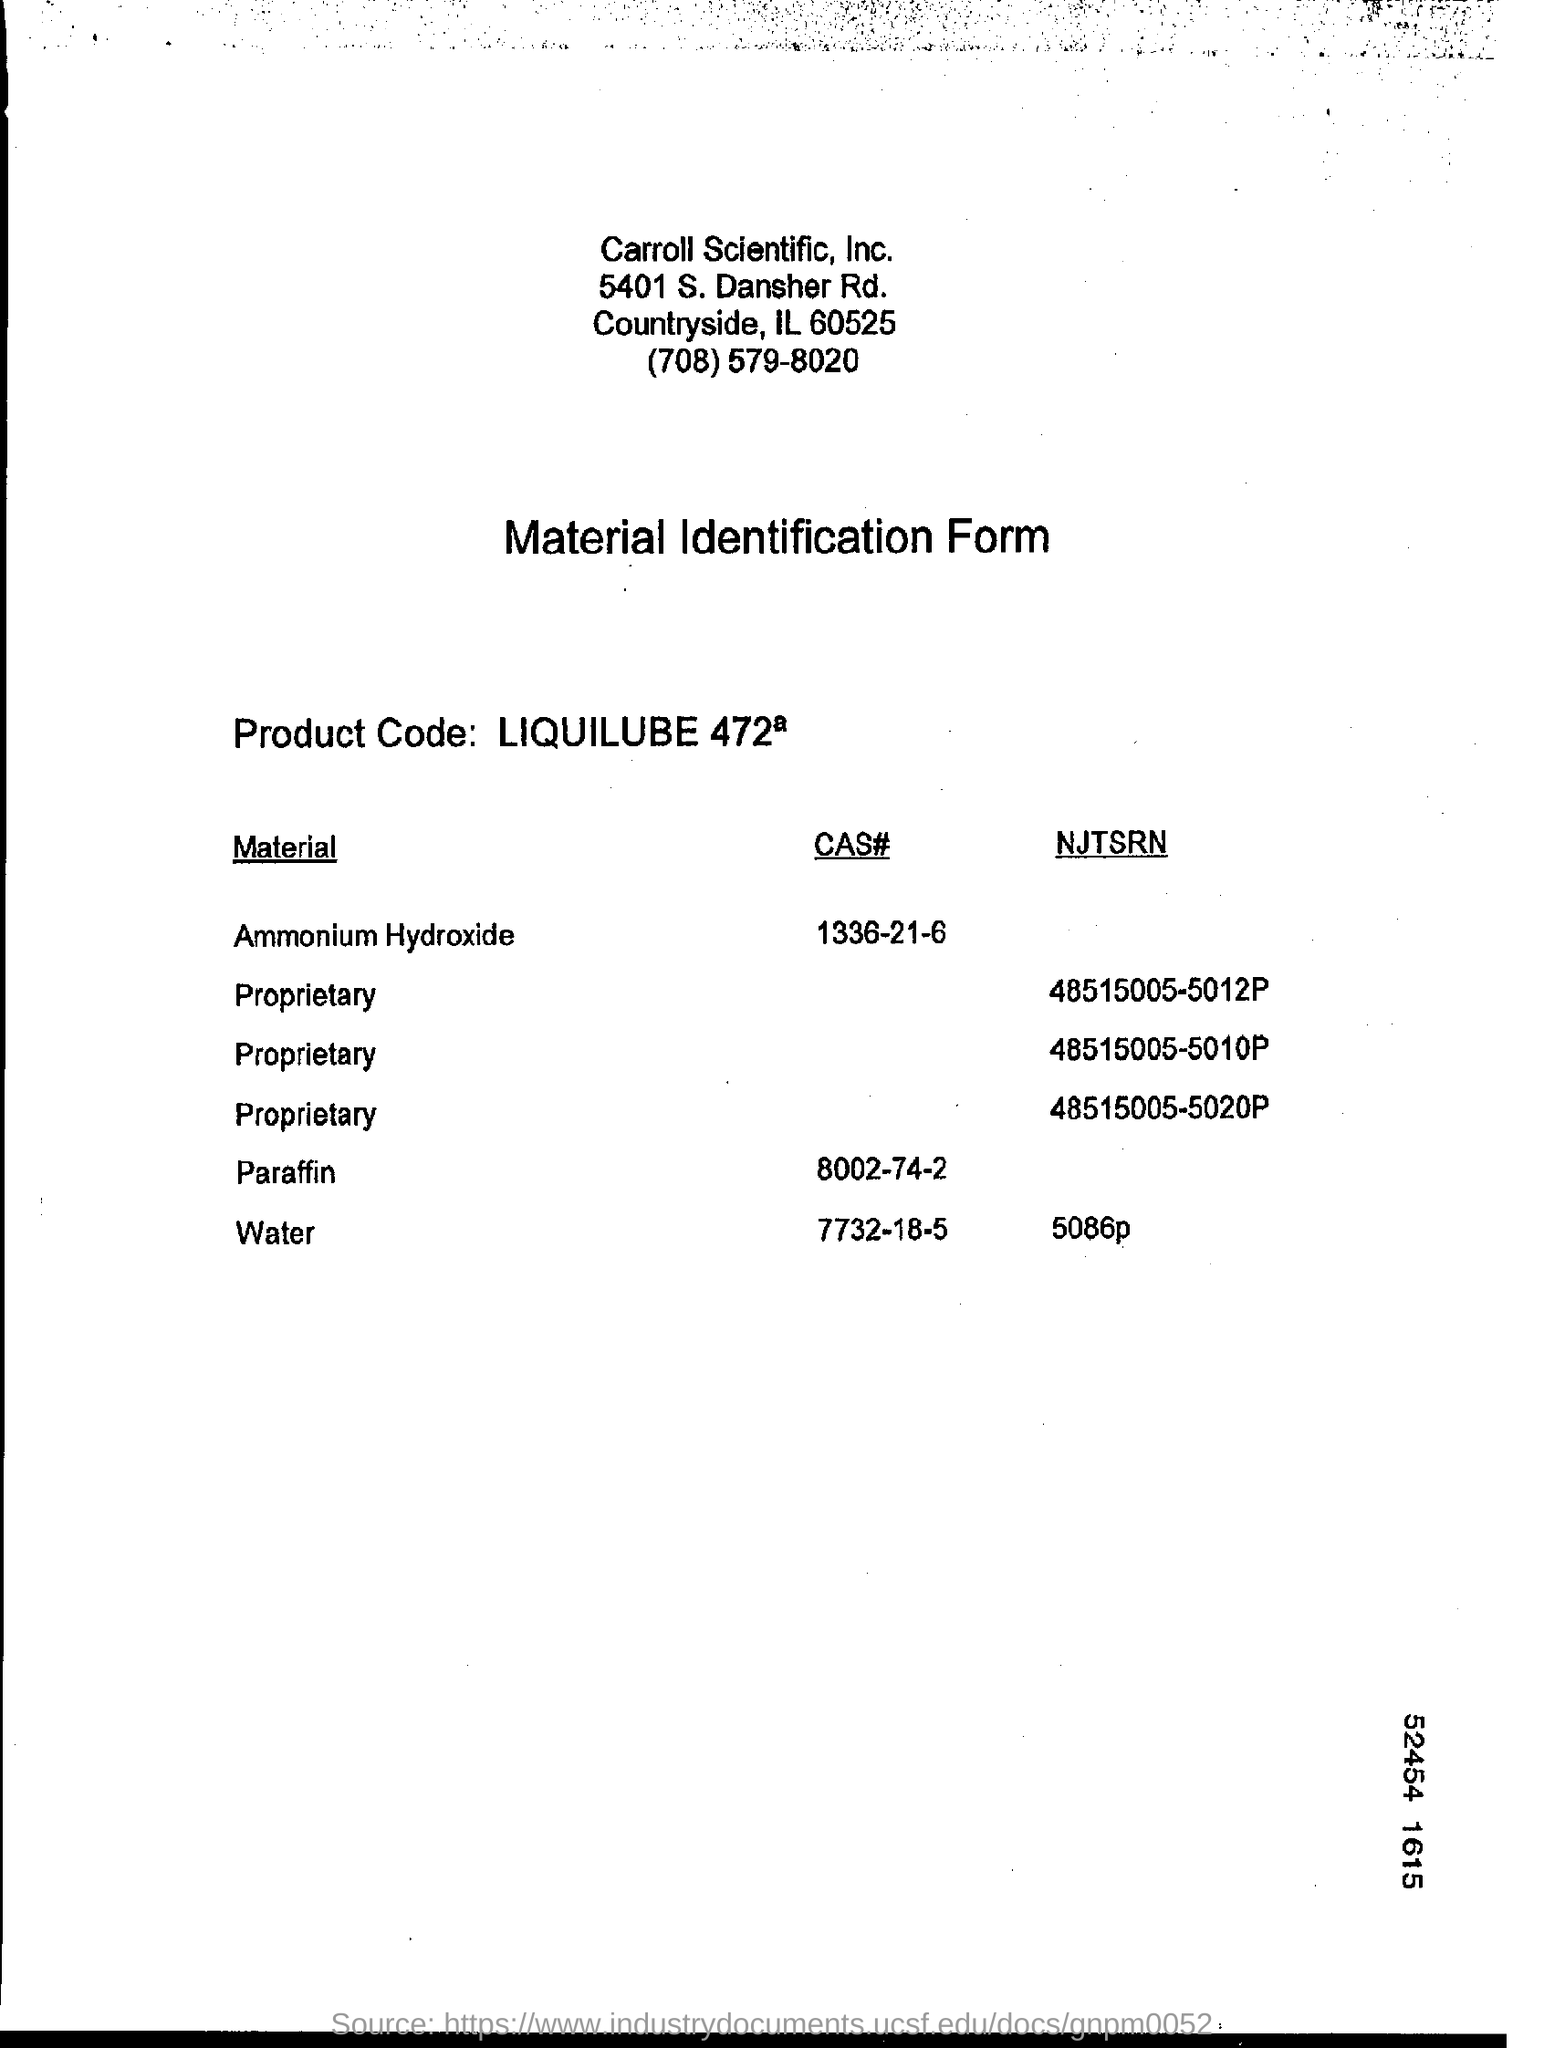Highlight a few significant elements in this photo. The NJTSRN of water is 5086 pounds per square inch. 